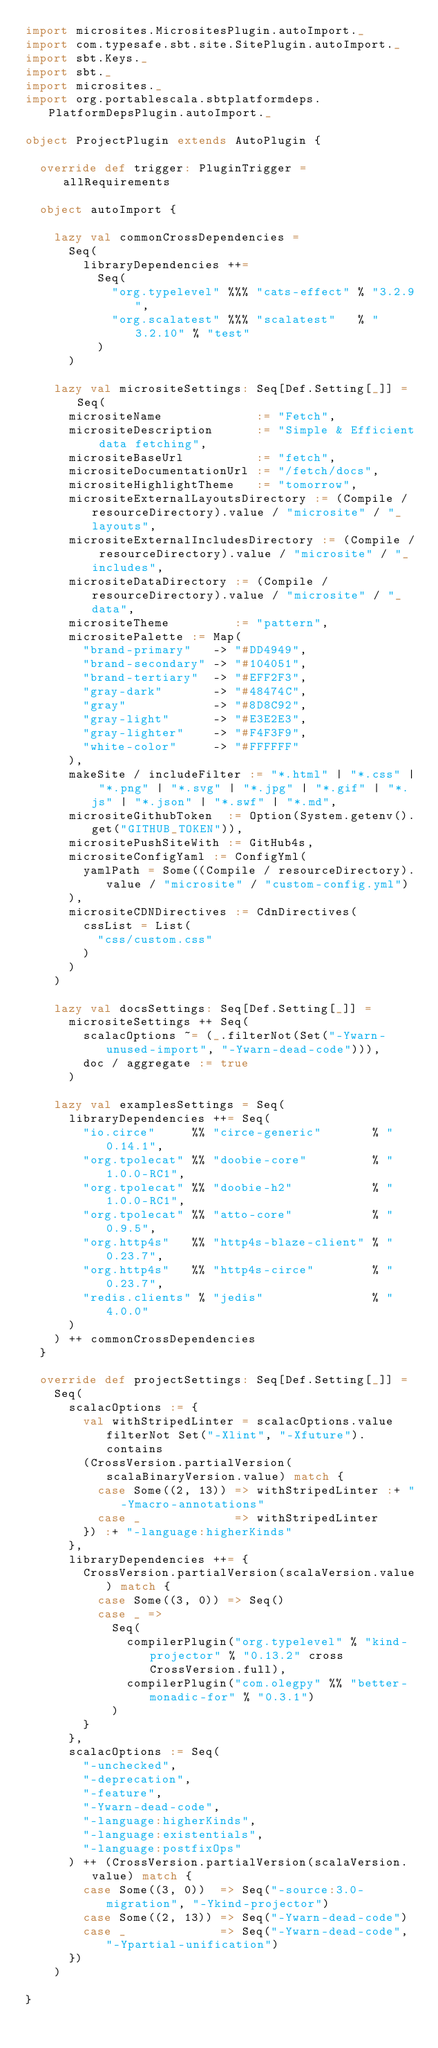Convert code to text. <code><loc_0><loc_0><loc_500><loc_500><_Scala_>import microsites.MicrositesPlugin.autoImport._
import com.typesafe.sbt.site.SitePlugin.autoImport._
import sbt.Keys._
import sbt._
import microsites._
import org.portablescala.sbtplatformdeps.PlatformDepsPlugin.autoImport._

object ProjectPlugin extends AutoPlugin {

  override def trigger: PluginTrigger = allRequirements

  object autoImport {

    lazy val commonCrossDependencies =
      Seq(
        libraryDependencies ++=
          Seq(
            "org.typelevel" %%% "cats-effect" % "3.2.9",
            "org.scalatest" %%% "scalatest"   % "3.2.10" % "test"
          )
      )

    lazy val micrositeSettings: Seq[Def.Setting[_]] = Seq(
      micrositeName             := "Fetch",
      micrositeDescription      := "Simple & Efficient data fetching",
      micrositeBaseUrl          := "fetch",
      micrositeDocumentationUrl := "/fetch/docs",
      micrositeHighlightTheme   := "tomorrow",
      micrositeExternalLayoutsDirectory := (Compile / resourceDirectory).value / "microsite" / "_layouts",
      micrositeExternalIncludesDirectory := (Compile / resourceDirectory).value / "microsite" / "_includes",
      micrositeDataDirectory := (Compile / resourceDirectory).value / "microsite" / "_data",
      micrositeTheme         := "pattern",
      micrositePalette := Map(
        "brand-primary"   -> "#DD4949",
        "brand-secondary" -> "#104051",
        "brand-tertiary"  -> "#EFF2F3",
        "gray-dark"       -> "#48474C",
        "gray"            -> "#8D8C92",
        "gray-light"      -> "#E3E2E3",
        "gray-lighter"    -> "#F4F3F9",
        "white-color"     -> "#FFFFFF"
      ),
      makeSite / includeFilter := "*.html" | "*.css" | "*.png" | "*.svg" | "*.jpg" | "*.gif" | "*.js" | "*.json" | "*.swf" | "*.md",
      micrositeGithubToken  := Option(System.getenv().get("GITHUB_TOKEN")),
      micrositePushSiteWith := GitHub4s,
      micrositeConfigYaml := ConfigYml(
        yamlPath = Some((Compile / resourceDirectory).value / "microsite" / "custom-config.yml")
      ),
      micrositeCDNDirectives := CdnDirectives(
        cssList = List(
          "css/custom.css"
        )
      )
    )

    lazy val docsSettings: Seq[Def.Setting[_]] =
      micrositeSettings ++ Seq(
        scalacOptions ~= (_.filterNot(Set("-Ywarn-unused-import", "-Ywarn-dead-code"))),
        doc / aggregate := true
      )

    lazy val examplesSettings = Seq(
      libraryDependencies ++= Seq(
        "io.circe"     %% "circe-generic"       % "0.14.1",
        "org.tpolecat" %% "doobie-core"         % "1.0.0-RC1",
        "org.tpolecat" %% "doobie-h2"           % "1.0.0-RC1",
        "org.tpolecat" %% "atto-core"           % "0.9.5",
        "org.http4s"   %% "http4s-blaze-client" % "0.23.7",
        "org.http4s"   %% "http4s-circe"        % "0.23.7",
        "redis.clients" % "jedis"               % "4.0.0"
      )
    ) ++ commonCrossDependencies
  }

  override def projectSettings: Seq[Def.Setting[_]] =
    Seq(
      scalacOptions := {
        val withStripedLinter = scalacOptions.value filterNot Set("-Xlint", "-Xfuture").contains
        (CrossVersion.partialVersion(scalaBinaryVersion.value) match {
          case Some((2, 13)) => withStripedLinter :+ "-Ymacro-annotations"
          case _             => withStripedLinter
        }) :+ "-language:higherKinds"
      },
      libraryDependencies ++= {
        CrossVersion.partialVersion(scalaVersion.value) match {
          case Some((3, 0)) => Seq()
          case _ =>
            Seq(
              compilerPlugin("org.typelevel" % "kind-projector" % "0.13.2" cross CrossVersion.full),
              compilerPlugin("com.olegpy" %% "better-monadic-for" % "0.3.1")
            )
        }
      },
      scalacOptions := Seq(
        "-unchecked",
        "-deprecation",
        "-feature",
        "-Ywarn-dead-code",
        "-language:higherKinds",
        "-language:existentials",
        "-language:postfixOps"
      ) ++ (CrossVersion.partialVersion(scalaVersion.value) match {
        case Some((3, 0))  => Seq("-source:3.0-migration", "-Ykind-projector")
        case Some((2, 13)) => Seq("-Ywarn-dead-code")
        case _             => Seq("-Ywarn-dead-code", "-Ypartial-unification")
      })
    )

}
</code> 